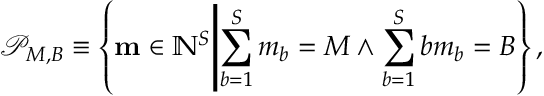<formula> <loc_0><loc_0><loc_500><loc_500>\mathcal { P } _ { M , B } \equiv \left \{ m \in \mathbb { N } ^ { S } | d l e | \sum _ { b = 1 } ^ { S } m _ { b } = M \land \sum _ { b = 1 } ^ { S } b m _ { b } = B \right \} ,</formula> 